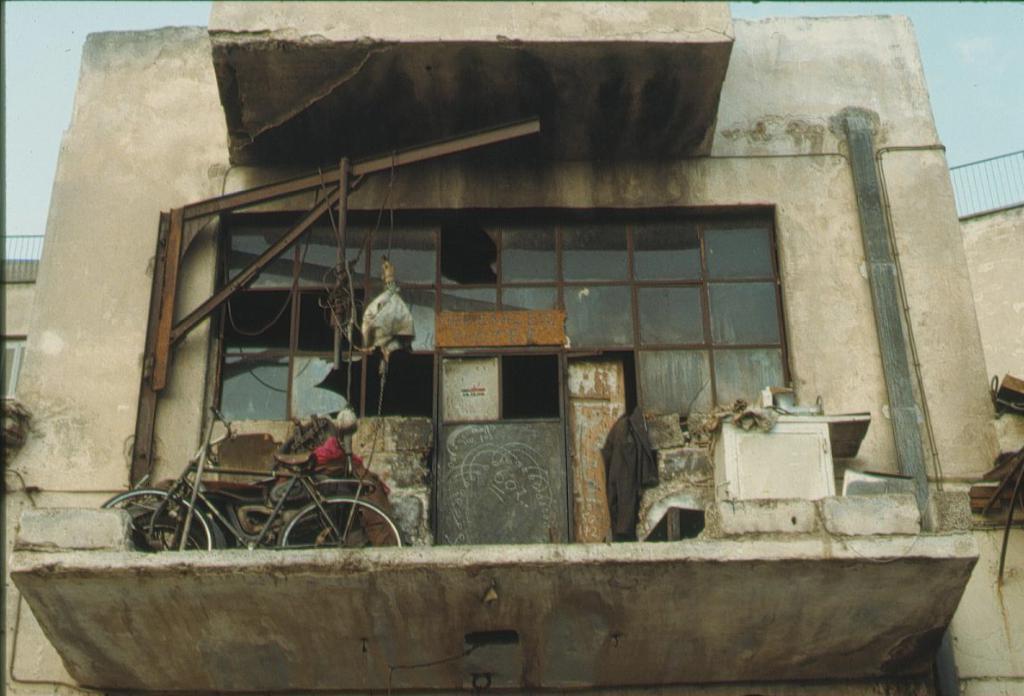In one or two sentences, can you explain what this image depicts? In the picture I can a bicycle, a door, framed glass wall, a building, fence and some other objects. In the background I can see the sky. 